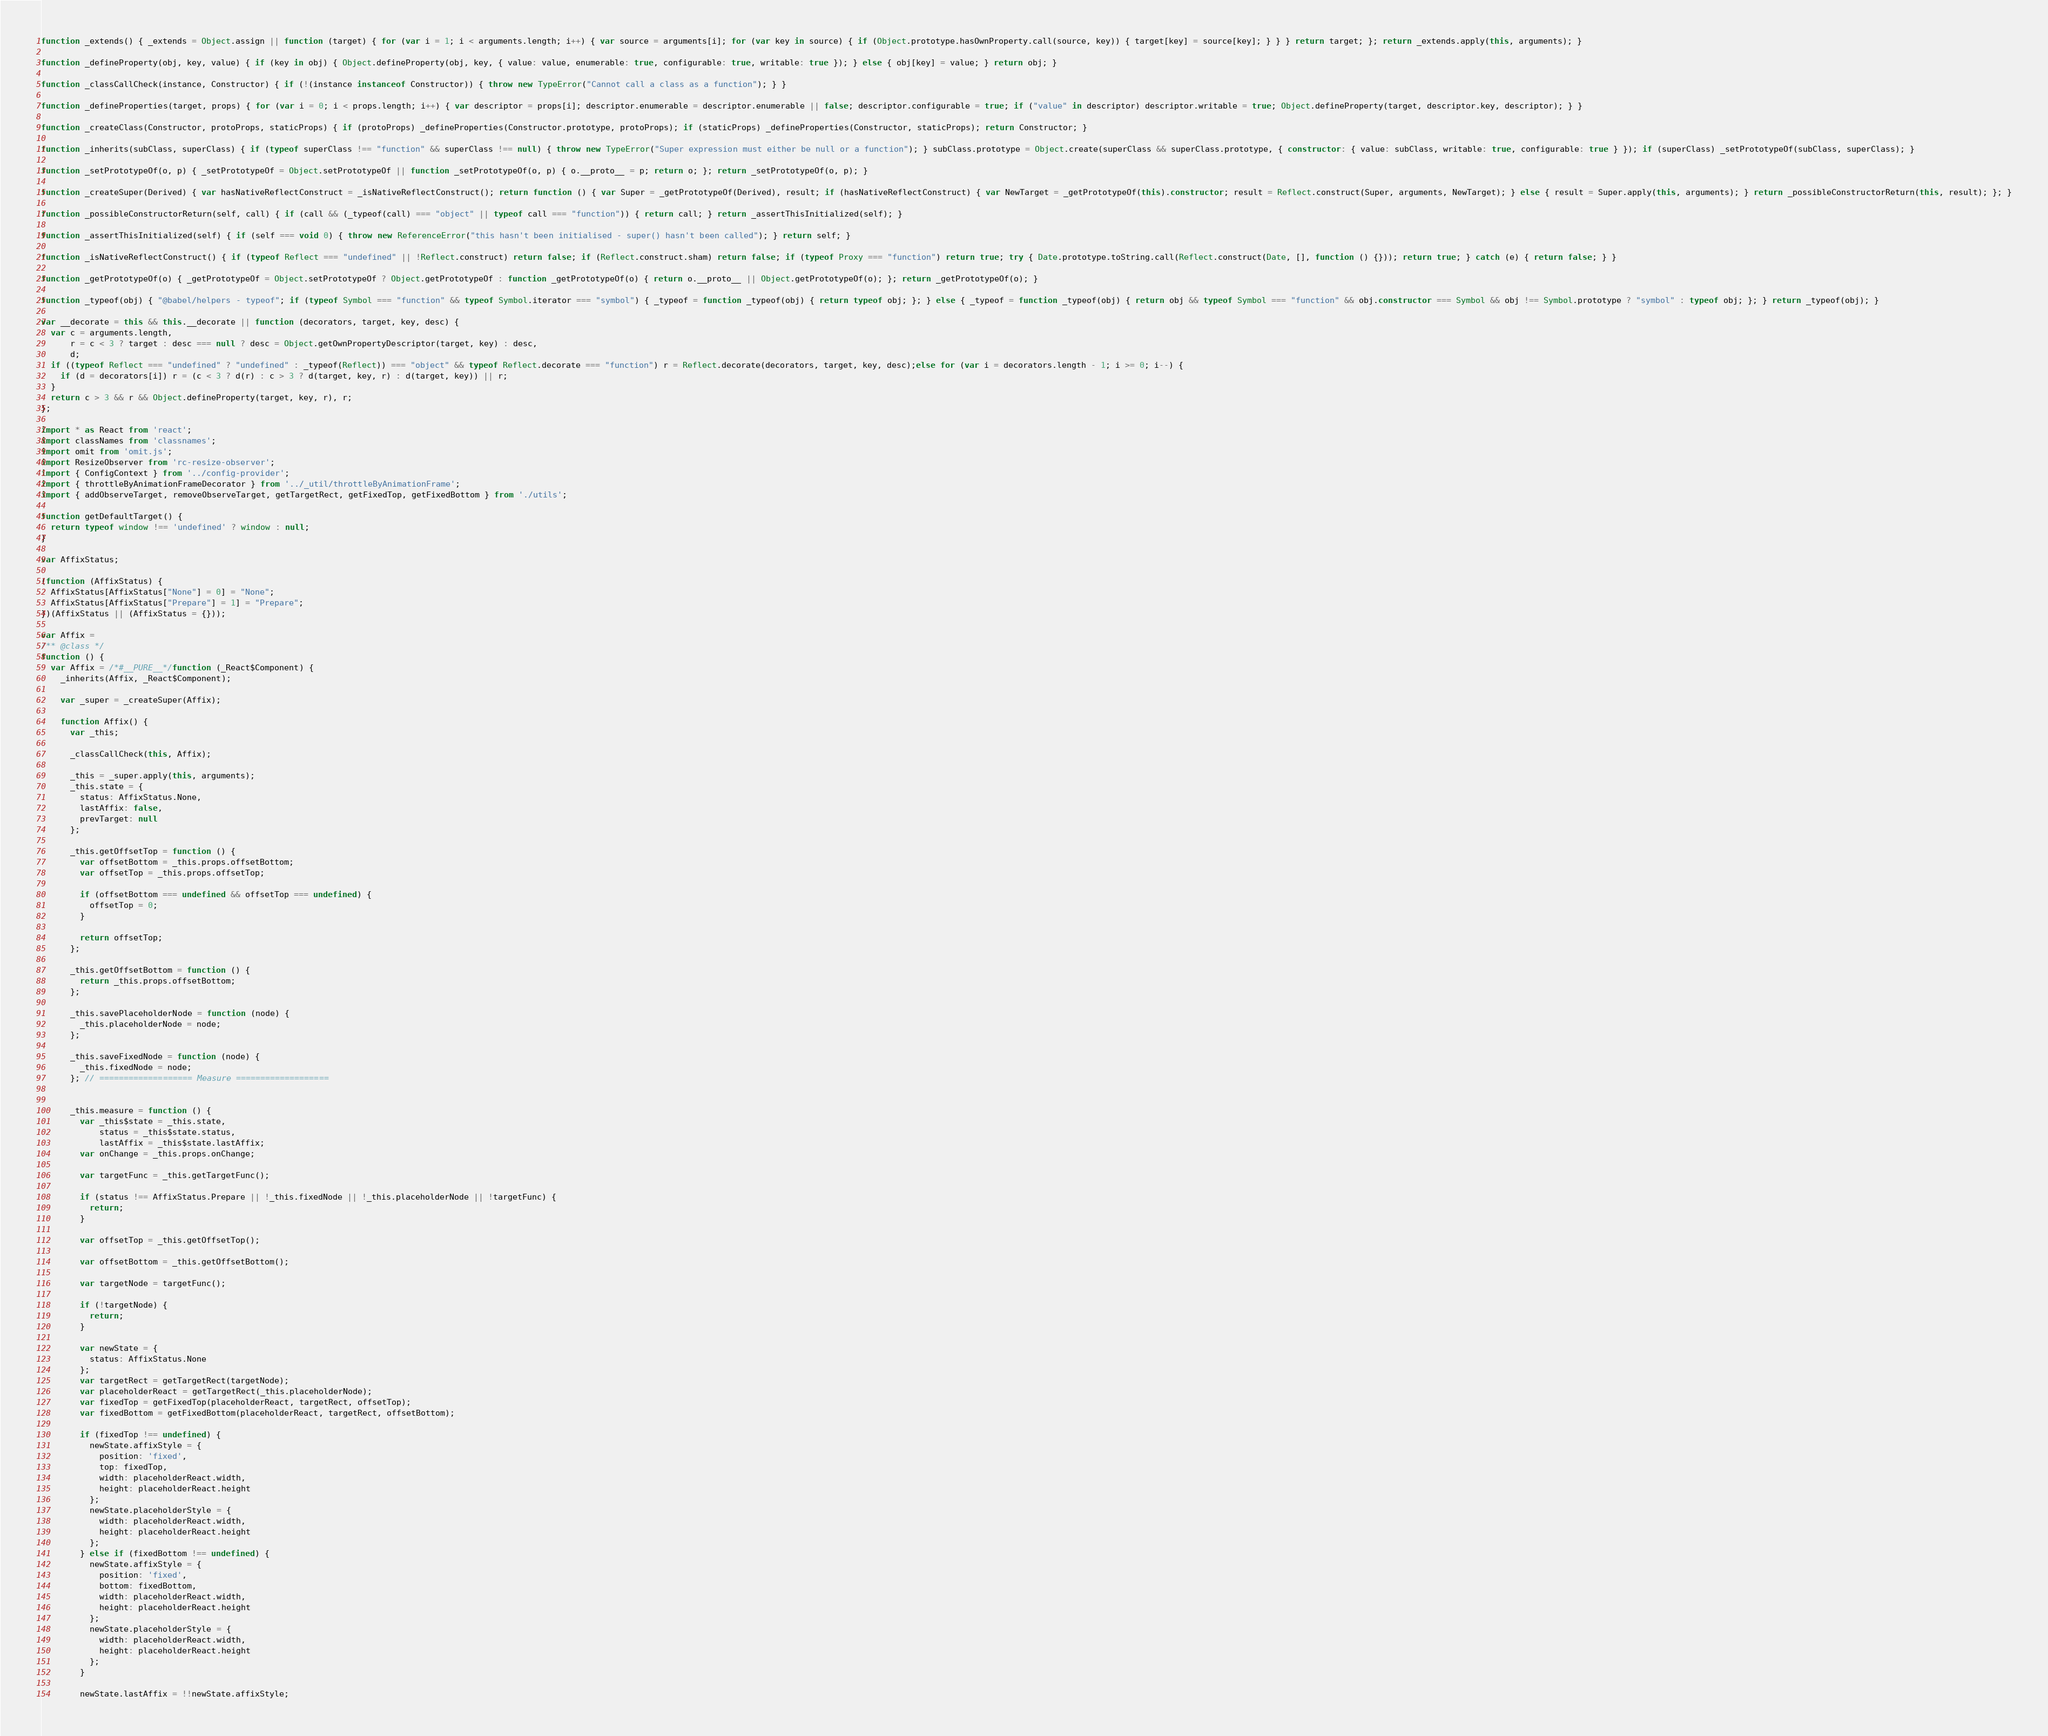Convert code to text. <code><loc_0><loc_0><loc_500><loc_500><_JavaScript_>function _extends() { _extends = Object.assign || function (target) { for (var i = 1; i < arguments.length; i++) { var source = arguments[i]; for (var key in source) { if (Object.prototype.hasOwnProperty.call(source, key)) { target[key] = source[key]; } } } return target; }; return _extends.apply(this, arguments); }

function _defineProperty(obj, key, value) { if (key in obj) { Object.defineProperty(obj, key, { value: value, enumerable: true, configurable: true, writable: true }); } else { obj[key] = value; } return obj; }

function _classCallCheck(instance, Constructor) { if (!(instance instanceof Constructor)) { throw new TypeError("Cannot call a class as a function"); } }

function _defineProperties(target, props) { for (var i = 0; i < props.length; i++) { var descriptor = props[i]; descriptor.enumerable = descriptor.enumerable || false; descriptor.configurable = true; if ("value" in descriptor) descriptor.writable = true; Object.defineProperty(target, descriptor.key, descriptor); } }

function _createClass(Constructor, protoProps, staticProps) { if (protoProps) _defineProperties(Constructor.prototype, protoProps); if (staticProps) _defineProperties(Constructor, staticProps); return Constructor; }

function _inherits(subClass, superClass) { if (typeof superClass !== "function" && superClass !== null) { throw new TypeError("Super expression must either be null or a function"); } subClass.prototype = Object.create(superClass && superClass.prototype, { constructor: { value: subClass, writable: true, configurable: true } }); if (superClass) _setPrototypeOf(subClass, superClass); }

function _setPrototypeOf(o, p) { _setPrototypeOf = Object.setPrototypeOf || function _setPrototypeOf(o, p) { o.__proto__ = p; return o; }; return _setPrototypeOf(o, p); }

function _createSuper(Derived) { var hasNativeReflectConstruct = _isNativeReflectConstruct(); return function () { var Super = _getPrototypeOf(Derived), result; if (hasNativeReflectConstruct) { var NewTarget = _getPrototypeOf(this).constructor; result = Reflect.construct(Super, arguments, NewTarget); } else { result = Super.apply(this, arguments); } return _possibleConstructorReturn(this, result); }; }

function _possibleConstructorReturn(self, call) { if (call && (_typeof(call) === "object" || typeof call === "function")) { return call; } return _assertThisInitialized(self); }

function _assertThisInitialized(self) { if (self === void 0) { throw new ReferenceError("this hasn't been initialised - super() hasn't been called"); } return self; }

function _isNativeReflectConstruct() { if (typeof Reflect === "undefined" || !Reflect.construct) return false; if (Reflect.construct.sham) return false; if (typeof Proxy === "function") return true; try { Date.prototype.toString.call(Reflect.construct(Date, [], function () {})); return true; } catch (e) { return false; } }

function _getPrototypeOf(o) { _getPrototypeOf = Object.setPrototypeOf ? Object.getPrototypeOf : function _getPrototypeOf(o) { return o.__proto__ || Object.getPrototypeOf(o); }; return _getPrototypeOf(o); }

function _typeof(obj) { "@babel/helpers - typeof"; if (typeof Symbol === "function" && typeof Symbol.iterator === "symbol") { _typeof = function _typeof(obj) { return typeof obj; }; } else { _typeof = function _typeof(obj) { return obj && typeof Symbol === "function" && obj.constructor === Symbol && obj !== Symbol.prototype ? "symbol" : typeof obj; }; } return _typeof(obj); }

var __decorate = this && this.__decorate || function (decorators, target, key, desc) {
  var c = arguments.length,
      r = c < 3 ? target : desc === null ? desc = Object.getOwnPropertyDescriptor(target, key) : desc,
      d;
  if ((typeof Reflect === "undefined" ? "undefined" : _typeof(Reflect)) === "object" && typeof Reflect.decorate === "function") r = Reflect.decorate(decorators, target, key, desc);else for (var i = decorators.length - 1; i >= 0; i--) {
    if (d = decorators[i]) r = (c < 3 ? d(r) : c > 3 ? d(target, key, r) : d(target, key)) || r;
  }
  return c > 3 && r && Object.defineProperty(target, key, r), r;
};

import * as React from 'react';
import classNames from 'classnames';
import omit from 'omit.js';
import ResizeObserver from 'rc-resize-observer';
import { ConfigContext } from '../config-provider';
import { throttleByAnimationFrameDecorator } from '../_util/throttleByAnimationFrame';
import { addObserveTarget, removeObserveTarget, getTargetRect, getFixedTop, getFixedBottom } from './utils';

function getDefaultTarget() {
  return typeof window !== 'undefined' ? window : null;
}

var AffixStatus;

(function (AffixStatus) {
  AffixStatus[AffixStatus["None"] = 0] = "None";
  AffixStatus[AffixStatus["Prepare"] = 1] = "Prepare";
})(AffixStatus || (AffixStatus = {}));

var Affix =
/** @class */
function () {
  var Affix = /*#__PURE__*/function (_React$Component) {
    _inherits(Affix, _React$Component);

    var _super = _createSuper(Affix);

    function Affix() {
      var _this;

      _classCallCheck(this, Affix);

      _this = _super.apply(this, arguments);
      _this.state = {
        status: AffixStatus.None,
        lastAffix: false,
        prevTarget: null
      };

      _this.getOffsetTop = function () {
        var offsetBottom = _this.props.offsetBottom;
        var offsetTop = _this.props.offsetTop;

        if (offsetBottom === undefined && offsetTop === undefined) {
          offsetTop = 0;
        }

        return offsetTop;
      };

      _this.getOffsetBottom = function () {
        return _this.props.offsetBottom;
      };

      _this.savePlaceholderNode = function (node) {
        _this.placeholderNode = node;
      };

      _this.saveFixedNode = function (node) {
        _this.fixedNode = node;
      }; // =================== Measure ===================


      _this.measure = function () {
        var _this$state = _this.state,
            status = _this$state.status,
            lastAffix = _this$state.lastAffix;
        var onChange = _this.props.onChange;

        var targetFunc = _this.getTargetFunc();

        if (status !== AffixStatus.Prepare || !_this.fixedNode || !_this.placeholderNode || !targetFunc) {
          return;
        }

        var offsetTop = _this.getOffsetTop();

        var offsetBottom = _this.getOffsetBottom();

        var targetNode = targetFunc();

        if (!targetNode) {
          return;
        }

        var newState = {
          status: AffixStatus.None
        };
        var targetRect = getTargetRect(targetNode);
        var placeholderReact = getTargetRect(_this.placeholderNode);
        var fixedTop = getFixedTop(placeholderReact, targetRect, offsetTop);
        var fixedBottom = getFixedBottom(placeholderReact, targetRect, offsetBottom);

        if (fixedTop !== undefined) {
          newState.affixStyle = {
            position: 'fixed',
            top: fixedTop,
            width: placeholderReact.width,
            height: placeholderReact.height
          };
          newState.placeholderStyle = {
            width: placeholderReact.width,
            height: placeholderReact.height
          };
        } else if (fixedBottom !== undefined) {
          newState.affixStyle = {
            position: 'fixed',
            bottom: fixedBottom,
            width: placeholderReact.width,
            height: placeholderReact.height
          };
          newState.placeholderStyle = {
            width: placeholderReact.width,
            height: placeholderReact.height
          };
        }

        newState.lastAffix = !!newState.affixStyle;
</code> 